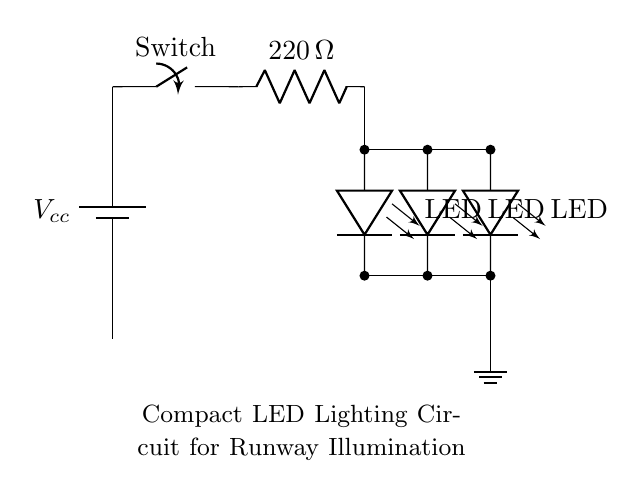What is the voltage source in this circuit? The circuit has a voltage source labeled Vcc, which is typically a battery or power supply providing the necessary voltage.
Answer: Vcc What type of switch is used in this circuit? The switch in the circuit is labeled simply as "Switch," indicating it is a basic manual switch that can open or close the circuit.
Answer: Switch How many LEDs are present in this circuit? There are a total of three LEDs in the circuit, indicated by the LED symbol used three times in the diagram.
Answer: Three What is the value of the resistor used in this circuit? The resistor is labeled with a value of 220 ohms, which is crucial for limiting current to prevent LED damage.
Answer: 220 ohm What does the parallel arrangement of the LED symbolize? The parallel arrangement of the LEDs allows each LED to operate independently, ensuring that if one LED fails, the others still light up.
Answer: Parallel operation Why is a resistor needed in this circuit? A resistor is needed to limit the current flowing through the LEDs, preventing them from drawing too much current and burning out.
Answer: To limit current What happens when the switch is closed? When the switch is closed, current flows from the voltage source through the resistor and LEDs, illuminating them for runway lighting.
Answer: LEDs illuminate 